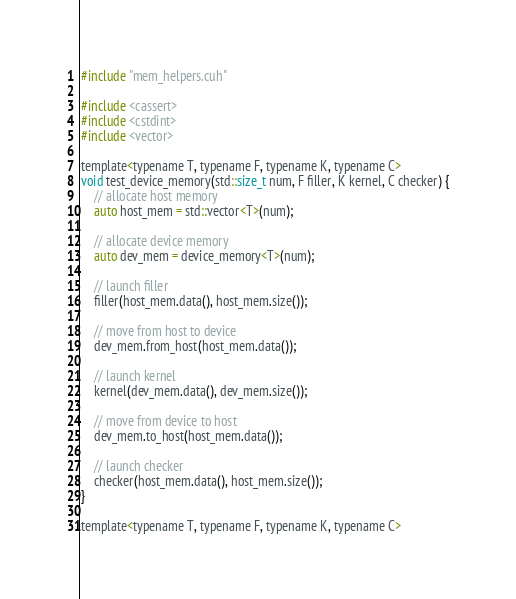<code> <loc_0><loc_0><loc_500><loc_500><_Cuda_>#include "mem_helpers.cuh"

#include <cassert>
#include <cstdint>
#include <vector>

template<typename T, typename F, typename K, typename C>
void test_device_memory(std::size_t num, F filler, K kernel, C checker) {
    // allocate host memory
    auto host_mem = std::vector<T>(num);

    // allocate device memory
    auto dev_mem = device_memory<T>(num);

    // launch filler
    filler(host_mem.data(), host_mem.size());

    // move from host to device
    dev_mem.from_host(host_mem.data());

    // launch kernel
    kernel(dev_mem.data(), dev_mem.size());

    // move from device to host
    dev_mem.to_host(host_mem.data());

    // launch checker
    checker(host_mem.data(), host_mem.size());
}

template<typename T, typename F, typename K, typename C></code> 